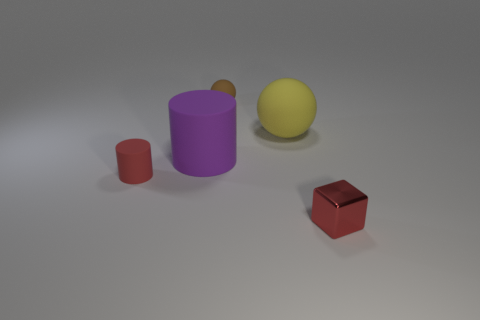Add 3 purple cylinders. How many objects exist? 8 Subtract all cubes. How many objects are left? 4 Subtract all yellow spheres. Subtract all big purple cylinders. How many objects are left? 3 Add 3 tiny red shiny things. How many tiny red shiny things are left? 4 Add 5 gray spheres. How many gray spheres exist? 5 Subtract 1 brown balls. How many objects are left? 4 Subtract 1 spheres. How many spheres are left? 1 Subtract all brown cylinders. Subtract all green spheres. How many cylinders are left? 2 